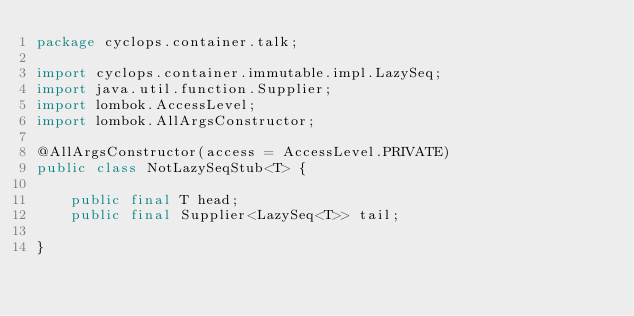<code> <loc_0><loc_0><loc_500><loc_500><_Java_>package cyclops.container.talk;

import cyclops.container.immutable.impl.LazySeq;
import java.util.function.Supplier;
import lombok.AccessLevel;
import lombok.AllArgsConstructor;

@AllArgsConstructor(access = AccessLevel.PRIVATE)
public class NotLazySeqStub<T> {

    public final T head;
    public final Supplier<LazySeq<T>> tail;

}
</code> 